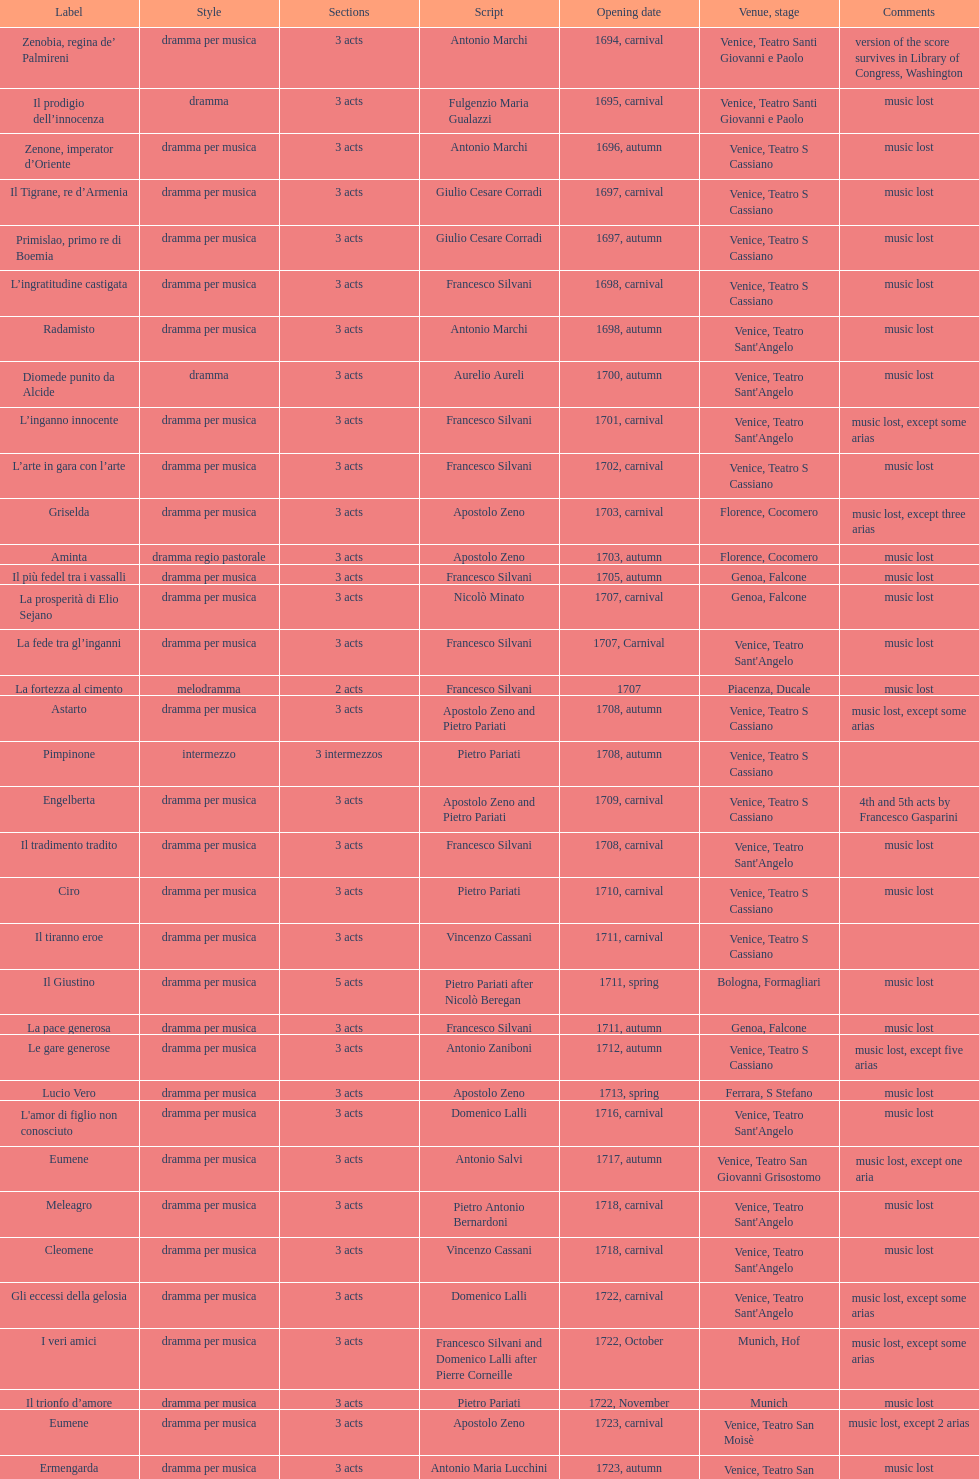Which opera has at least 5 acts? Il Giustino. 